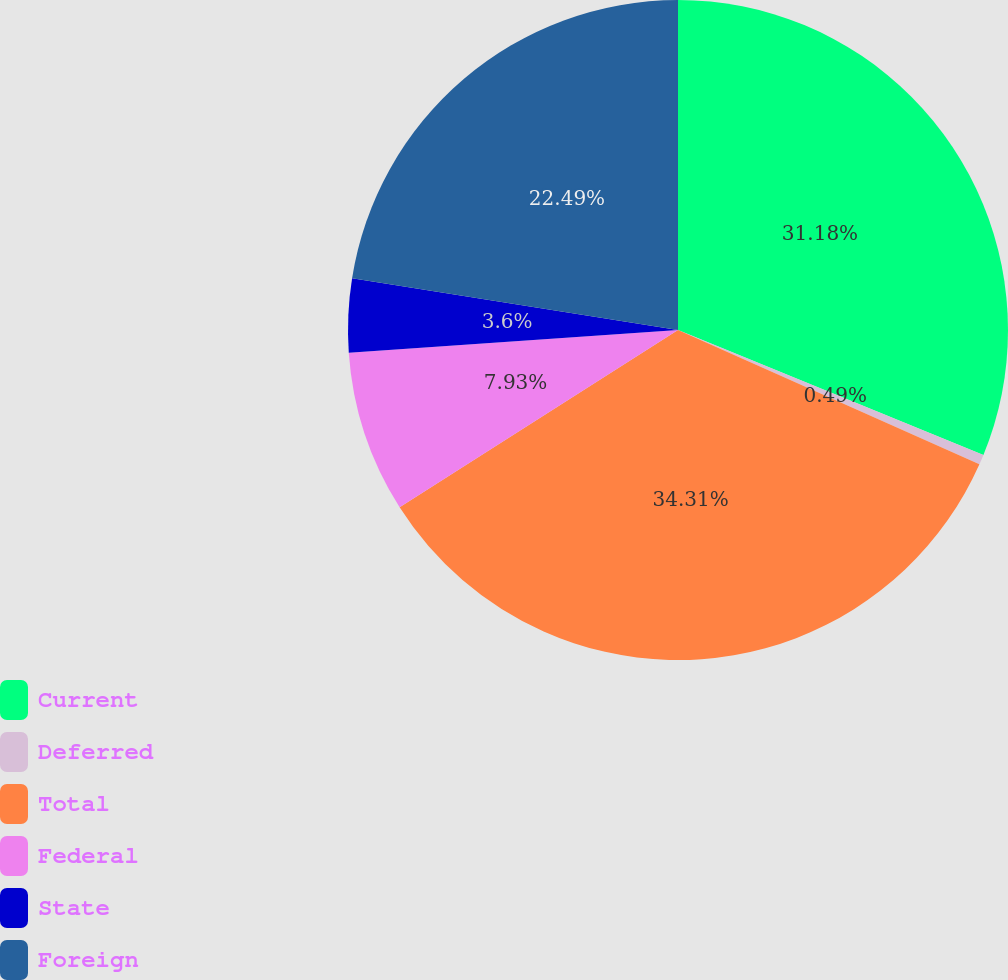Convert chart to OTSL. <chart><loc_0><loc_0><loc_500><loc_500><pie_chart><fcel>Current<fcel>Deferred<fcel>Total<fcel>Federal<fcel>State<fcel>Foreign<nl><fcel>31.18%<fcel>0.49%<fcel>34.3%<fcel>7.93%<fcel>3.6%<fcel>22.49%<nl></chart> 